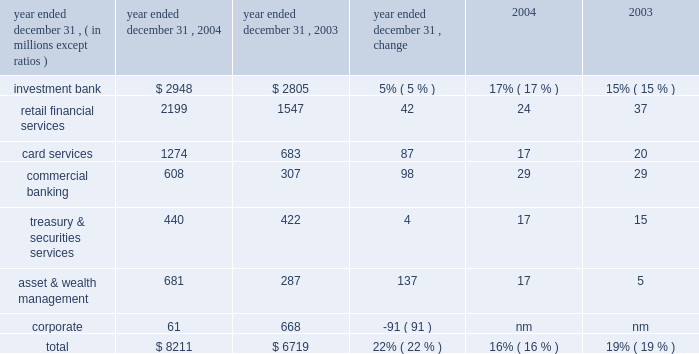Jpmorgan chase & co .
/ 2004 annual report 29 firms were aligned to provide consistency across the business segments .
In addition , expenses related to certain corporate functions , technology and operations ceased to be allocated to the business segments and are retained in corporate .
These retained expenses include parent company costs that would not be incurred if the segments were stand-alone businesses ; adjustments to align certain corporate staff , technology and operations allocations with market prices ; and other one-time items not aligned with the business segments .
Capital allocation each business segment is allocated capital by taking into consideration stand- alone peer comparisons , economic risk measures and regulatory capital requirements .
The amount of capital assigned to each business is referred to as equity .
Effective with the third quarter of 2004 , new methodologies were implemented to calculate the amount of capital allocated to each segment .
As part of the new methodology , goodwill , as well as the associated capital , is allocated solely to corporate .
Although u.s .
Gaap requires the allocation of goodwill to the business segments for impairment testing ( see note 15 on page 109 of this annual report ) , the firm has elected not to include goodwill or the related capital in each of the business segments for management reporting purposes .
See the capital management section on page 50 of this annual report for a discussion of the equity framework .
Credit reimbursement tss reimburses the ib for credit portfolio exposures the ib manages on behalf of clients the segments share .
At the time of the merger , the reimbursement methodology was revised to be based on pre-tax earnings , net of the cost of capital related to those exposures .
Prior to the merger , the credit reimburse- ment was based on pre-tax earnings , plus the allocated capital associated with the shared clients .
Tax-equivalent adjustments segment results reflect revenues on a tax-equivalent basis for segment reporting purposes .
Refer to page 25 of this annual report for additional details .
Description of business segment reporting methodology results of the business segments are intended to reflect each segment as if it were essentially a stand-alone business .
The management reporting process that derives these results allocates income and expense using market-based methodologies .
At the time of the merger , several of the allocation method- ologies were revised , as noted below .
The changes became effective july 1 , 2004 .
As prior periods have not been revised to reflect these new methodologies , they are not comparable to the presentation of periods begin- ning with the third quarter of 2004 .
Further , the firm intends to continue to assess the assumptions , methodologies and reporting reclassifications used for segment reporting , and it is anticipated that further refinements may be implemented in future periods .
Revenue sharing when business segments join efforts to sell products and services to the firm 2019s clients , the participating business segments agree to share revenues from those transactions .
These revenue sharing agreements were revised on the merger date to provide consistency across the lines of businesses .
Funds transfer pricing funds transfer pricing ( 201cftp 201d ) is used to allocate interest income and interest expense to each line of business and also serves to transfer interest rate risk to corporate .
While business segments may periodically retain interest rate exposures related to customer pricing or other business-specific risks , the bal- ance of the firm 2019s overall interest rate risk exposure is included and managed in corporate .
In the third quarter of 2004 , ftp was revised to conform the policies of the combined firms .
Expense allocation where business segments use services provided by support units within the firm , the costs of those support units are allocated to the business segments .
Those expenses are allocated based on their actual cost , or the lower of actual cost or market cost , as well as upon usage of the services provided .
Effective with the third quarter of 2004 , the cost allocation methodologies of the heritage segment results 2013 operating basis ( a ) ( b ) ( table continued from previous page ) year ended december 31 , operating earnings return on common equity 2013 goodwill ( c ) .

In 2004 , did retail financial services have a greater roe than card services? 
Computations: (24 > 17)
Answer: yes. 